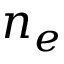<formula> <loc_0><loc_0><loc_500><loc_500>n _ { e }</formula> 